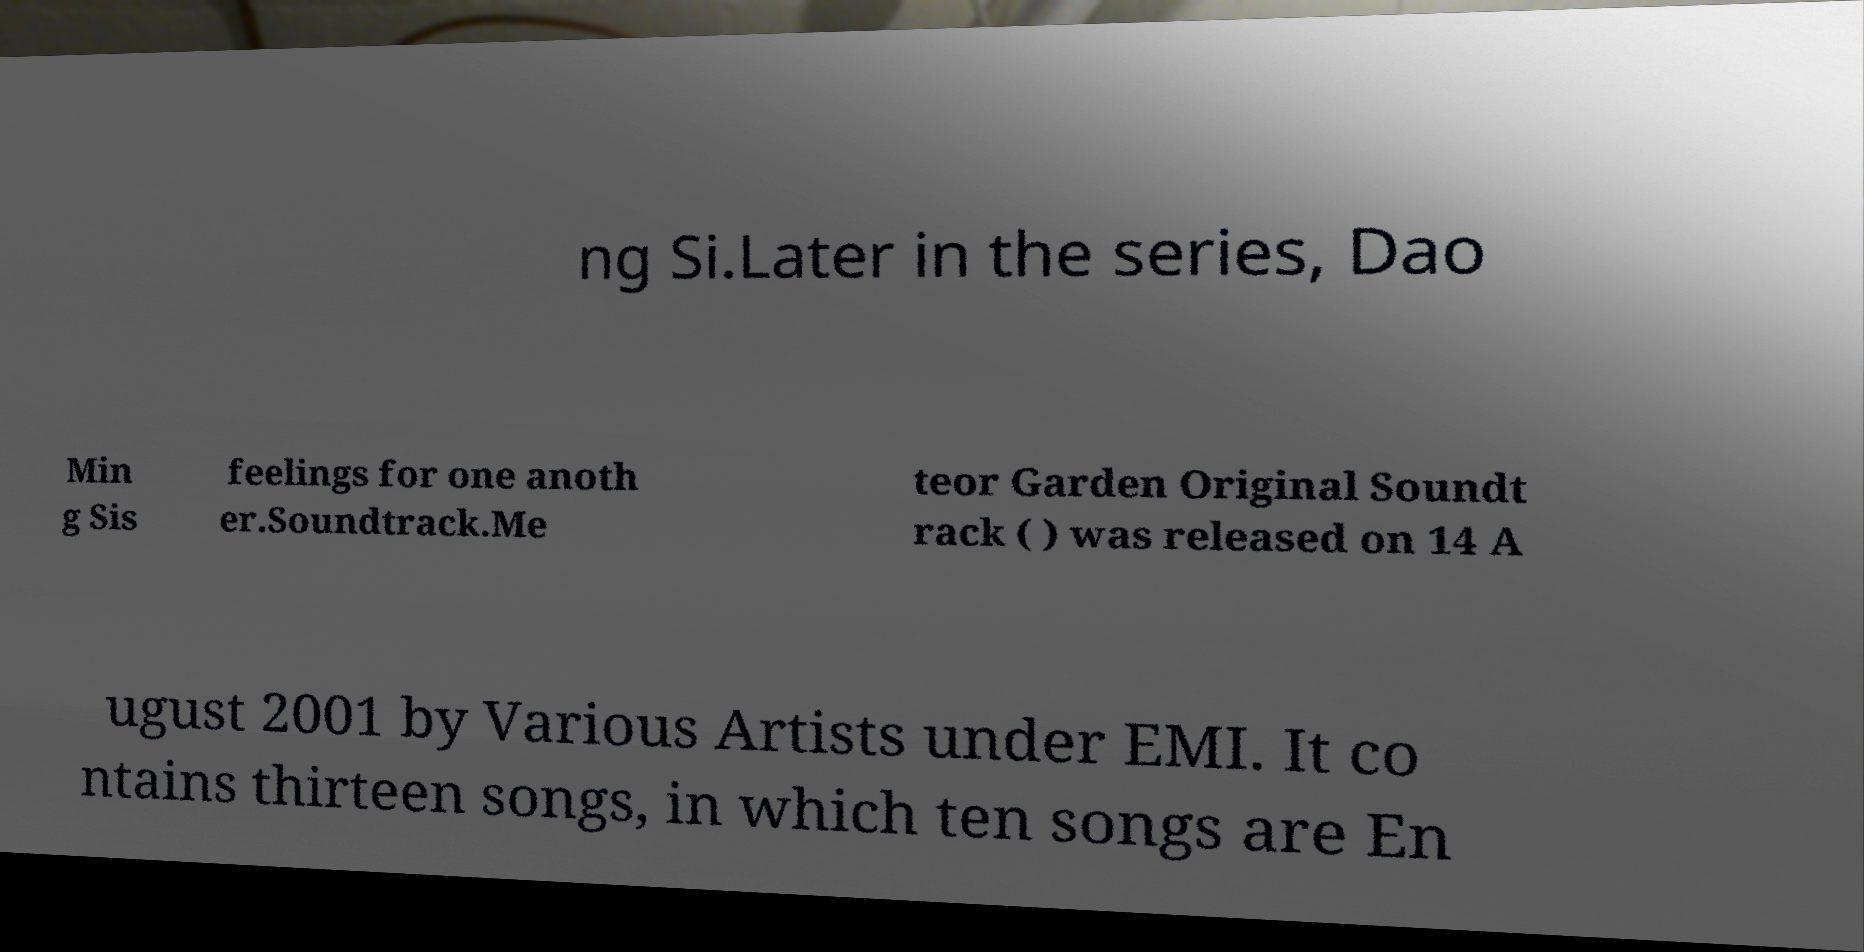There's text embedded in this image that I need extracted. Can you transcribe it verbatim? ng Si.Later in the series, Dao Min g Sis feelings for one anoth er.Soundtrack.Me teor Garden Original Soundt rack ( ) was released on 14 A ugust 2001 by Various Artists under EMI. It co ntains thirteen songs, in which ten songs are En 